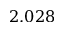Convert formula to latex. <formula><loc_0><loc_0><loc_500><loc_500>2 . 0 2 8</formula> 